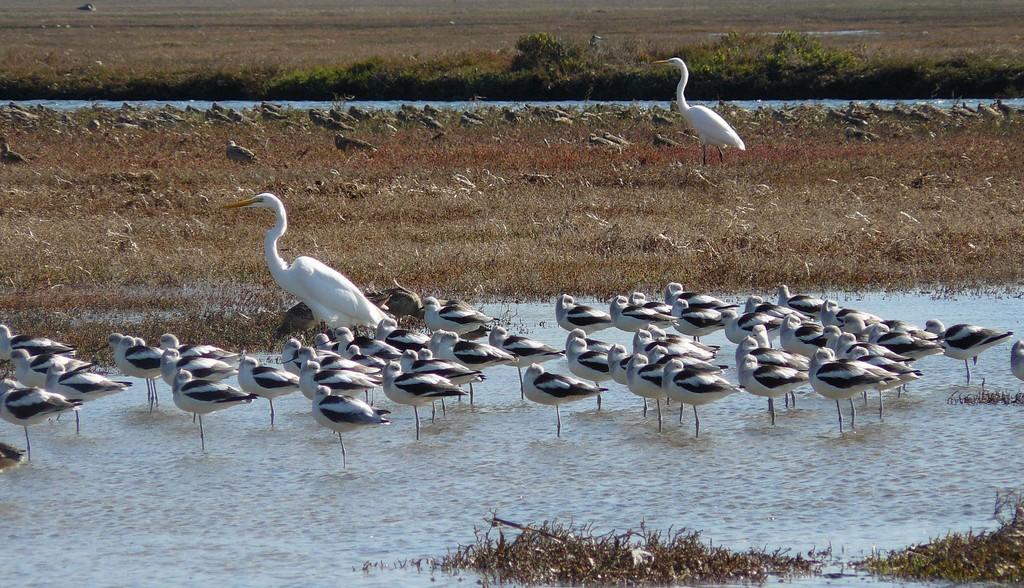How would you summarize this image in a sentence or two? This picture contains many swans. At the bottom of the picture, we see water and twigs. Behind the swans, we see grass. There are trees in the background. 